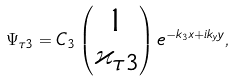Convert formula to latex. <formula><loc_0><loc_0><loc_500><loc_500>\Psi _ { \tau 3 } = C _ { 3 } \begin{pmatrix} 1 \\ \varkappa _ { \tau 3 } \end{pmatrix} e ^ { - k _ { 3 } x + i k _ { y } y } ,</formula> 